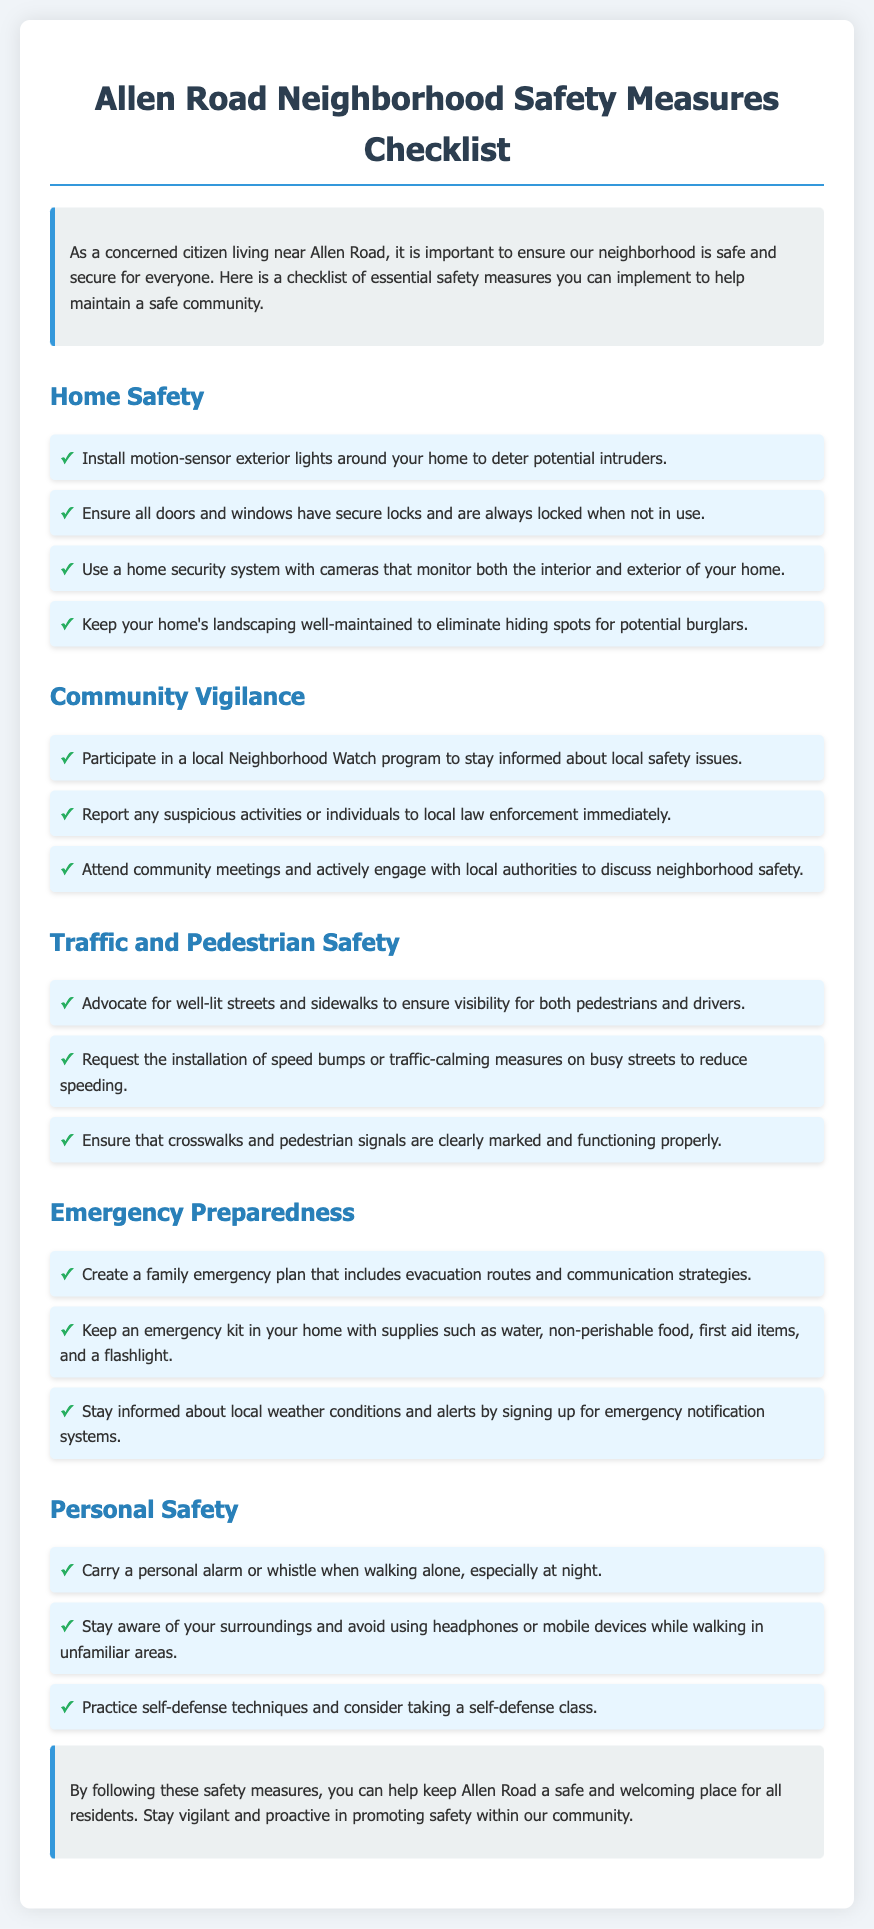What is the title of the document? The title is displayed prominently at the top of the document in a  header.
Answer: Allen Road Neighborhood Safety Measures Checklist How many sections are there in the checklist? The document contains different sections for various safety measures, each indicated by a heading.
Answer: Five What is one measure recommended for home safety? Home safety measures are listed in a specific section, detailing actions to enhance home security.
Answer: Install motion-sensor exterior lights What should you do if you see suspicious activity? The document advises specific actions to take in case of observing unusual behavior in the community.
Answer: Report to local law enforcement What is a suggested action to improve traffic safety? Traffic safety is addressed with a specific recommendation to enhance safety on the roads and sidewalks.
Answer: Advocate for well-lit streets How can you prepare for emergencies according to the checklist? Emergency preparedness measures are outlined, specifically relating to family safety strategies and supplies.
Answer: Create a family emergency plan What equipment should be in your emergency kit? The document specifies items that are essential for emergency preparedness in your home.
Answer: Water, non-perishable food, first aid items, flashlight What type of program can you join for community vigilance? Community vigilance suggestions emphasize participation in communal safety efforts.
Answer: Neighborhood Watch program What personal safety tool is mentioned for walking alone? Personal safety recommendations suggest carrying specific items to enhance individual security while outside.
Answer: Personal alarm or whistle 